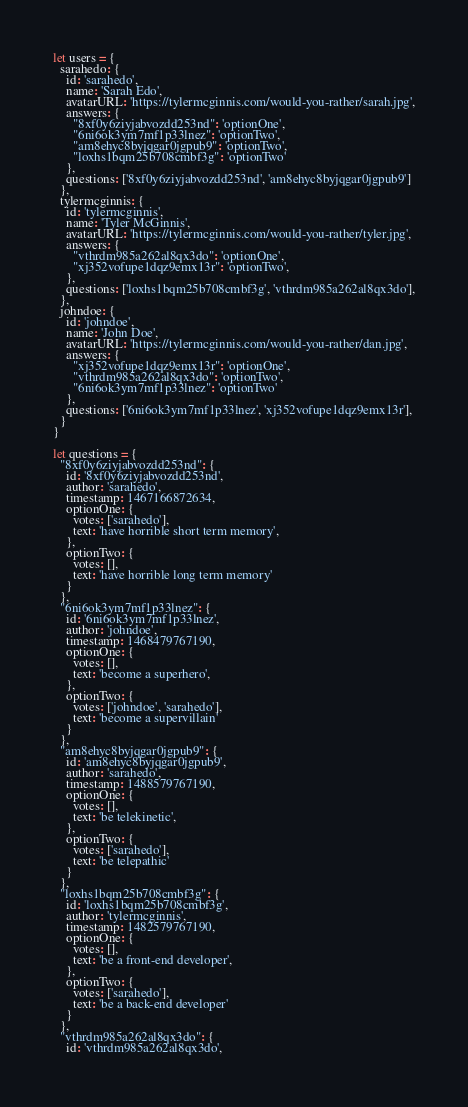Convert code to text. <code><loc_0><loc_0><loc_500><loc_500><_JavaScript_>let users = {
  sarahedo: {
    id: 'sarahedo',
    name: 'Sarah Edo',
    avatarURL: 'https://tylermcginnis.com/would-you-rather/sarah.jpg',
    answers: {
      "8xf0y6ziyjabvozdd253nd": 'optionOne',
      "6ni6ok3ym7mf1p33lnez": 'optionTwo',
      "am8ehyc8byjqgar0jgpub9": 'optionTwo',
      "loxhs1bqm25b708cmbf3g": 'optionTwo'
    },
    questions: ['8xf0y6ziyjabvozdd253nd', 'am8ehyc8byjqgar0jgpub9']
  },
  tylermcginnis: {
    id: 'tylermcginnis',
    name: 'Tyler McGinnis',
    avatarURL: 'https://tylermcginnis.com/would-you-rather/tyler.jpg',
    answers: {
      "vthrdm985a262al8qx3do": 'optionOne',
      "xj352vofupe1dqz9emx13r": 'optionTwo',
    },
    questions: ['loxhs1bqm25b708cmbf3g', 'vthrdm985a262al8qx3do'],
  },
  johndoe: {
    id: 'johndoe',
    name: 'John Doe',
    avatarURL: 'https://tylermcginnis.com/would-you-rather/dan.jpg',
    answers: {
      "xj352vofupe1dqz9emx13r": 'optionOne',
      "vthrdm985a262al8qx3do": 'optionTwo',
      "6ni6ok3ym7mf1p33lnez": 'optionTwo'
    },
    questions: ['6ni6ok3ym7mf1p33lnez', 'xj352vofupe1dqz9emx13r'],
  }
}

let questions = {
  "8xf0y6ziyjabvozdd253nd": {
    id: '8xf0y6ziyjabvozdd253nd',
    author: 'sarahedo',
    timestamp: 1467166872634,
    optionOne: {
      votes: ['sarahedo'],
      text: 'have horrible short term memory',
    },
    optionTwo: {
      votes: [],
      text: 'have horrible long term memory'
    }
  },
  "6ni6ok3ym7mf1p33lnez": {
    id: '6ni6ok3ym7mf1p33lnez',
    author: 'johndoe',
    timestamp: 1468479767190,
    optionOne: {
      votes: [],
      text: 'become a superhero',
    },
    optionTwo: {
      votes: ['johndoe', 'sarahedo'],
      text: 'become a supervillain'
    }
  },
  "am8ehyc8byjqgar0jgpub9": {
    id: 'am8ehyc8byjqgar0jgpub9',
    author: 'sarahedo',
    timestamp: 1488579767190,
    optionOne: {
      votes: [],
      text: 'be telekinetic',
    },
    optionTwo: {
      votes: ['sarahedo'],
      text: 'be telepathic'
    }
  },
  "loxhs1bqm25b708cmbf3g": {
    id: 'loxhs1bqm25b708cmbf3g',
    author: 'tylermcginnis',
    timestamp: 1482579767190,
    optionOne: {
      votes: [],
      text: 'be a front-end developer',
    },
    optionTwo: {
      votes: ['sarahedo'],
      text: 'be a back-end developer'
    }
  },
  "vthrdm985a262al8qx3do": {
    id: 'vthrdm985a262al8qx3do',</code> 